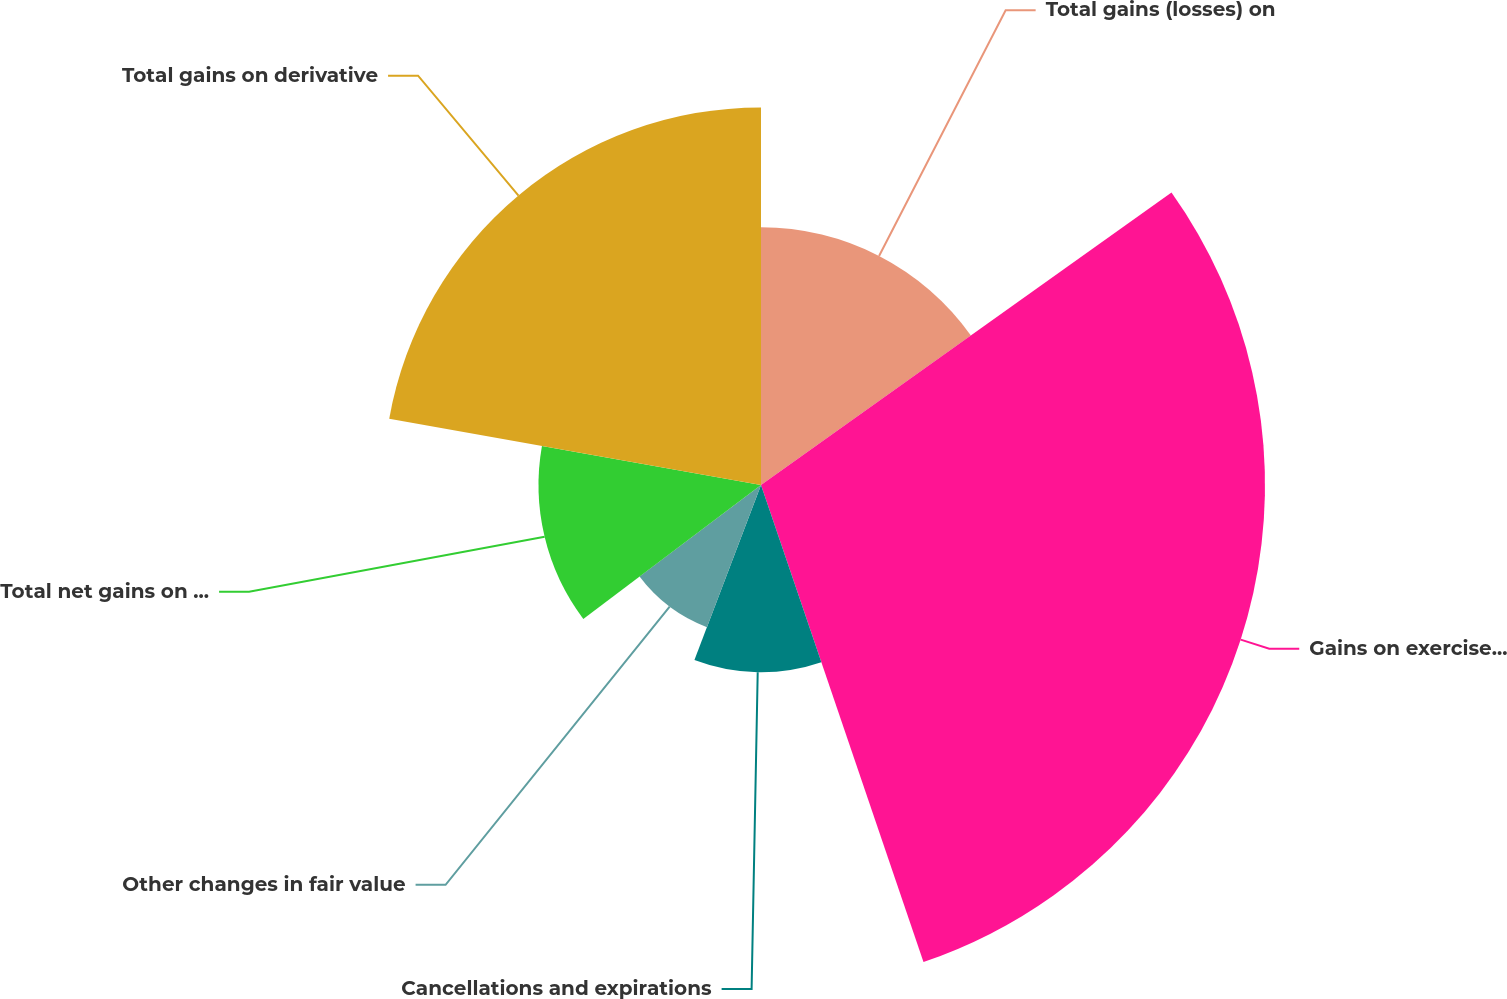Convert chart to OTSL. <chart><loc_0><loc_0><loc_500><loc_500><pie_chart><fcel>Total gains (losses) on<fcel>Gains on exercise net<fcel>Cancellations and expirations<fcel>Other changes in fair value<fcel>Total net gains on equity<fcel>Total gains on derivative<nl><fcel>15.15%<fcel>29.63%<fcel>11.01%<fcel>8.94%<fcel>13.08%<fcel>22.2%<nl></chart> 